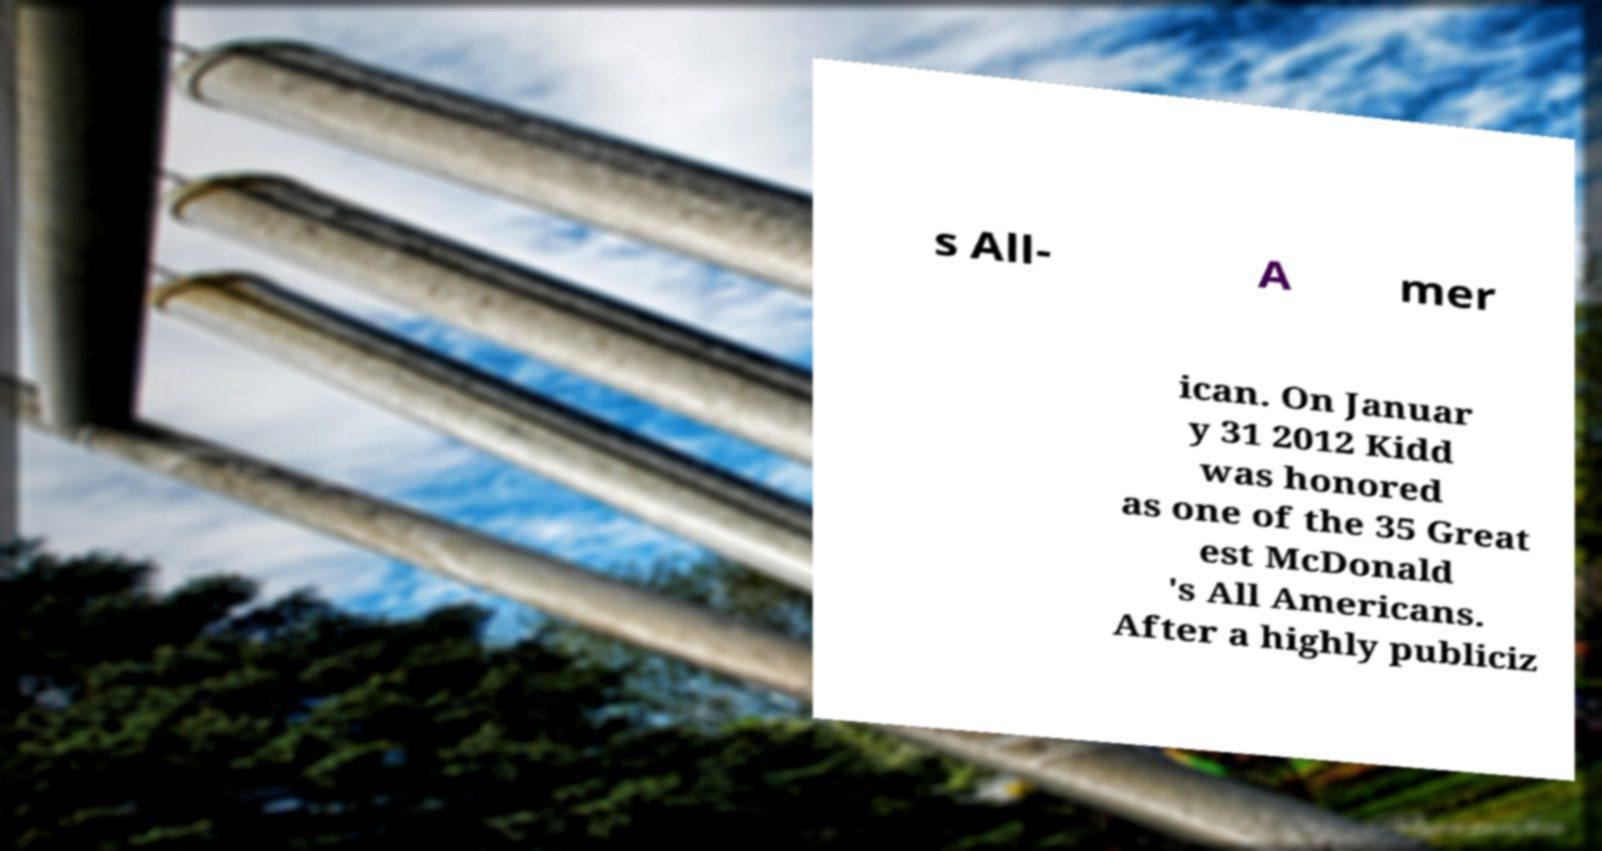Can you accurately transcribe the text from the provided image for me? s All- A mer ican. On Januar y 31 2012 Kidd was honored as one of the 35 Great est McDonald 's All Americans. After a highly publiciz 